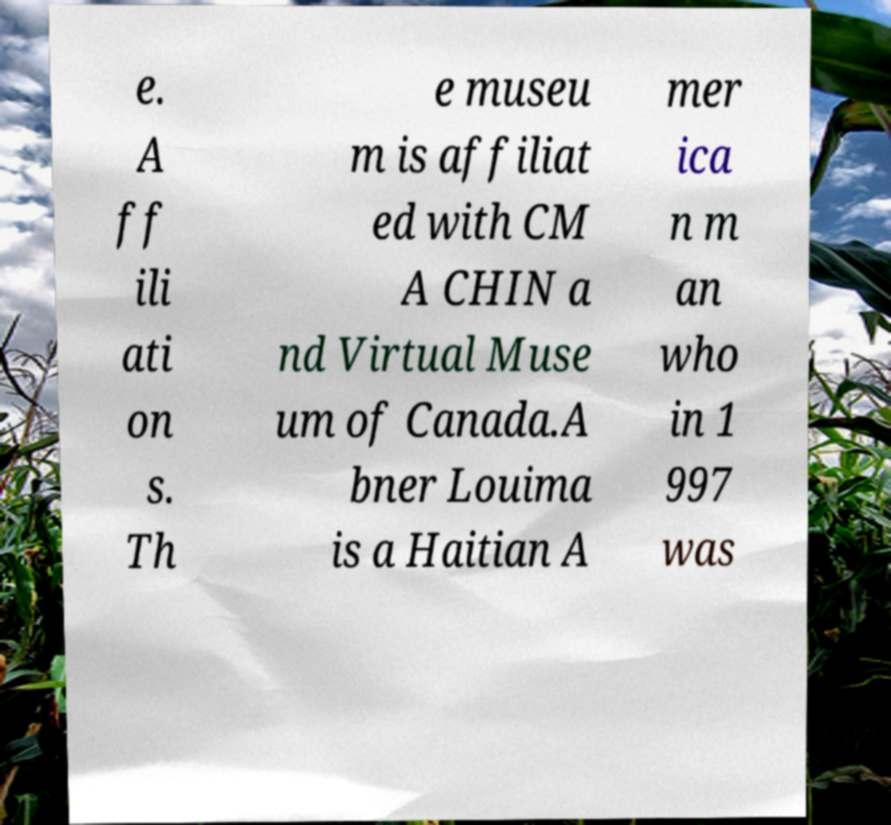Please read and relay the text visible in this image. What does it say? e. A ff ili ati on s. Th e museu m is affiliat ed with CM A CHIN a nd Virtual Muse um of Canada.A bner Louima is a Haitian A mer ica n m an who in 1 997 was 